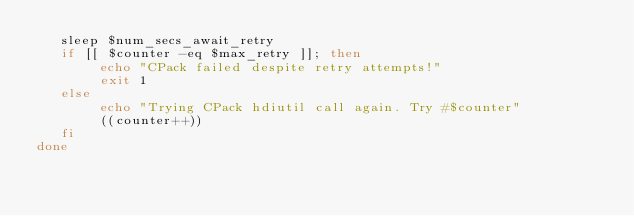<code> <loc_0><loc_0><loc_500><loc_500><_Bash_>   sleep $num_secs_await_retry
   if [[ $counter -eq $max_retry ]]; then
        echo "CPack failed despite retry attempts!"
        exit 1
   else
        echo "Trying CPack hdiutil call again. Try #$counter"
        ((counter++))
   fi
done
</code> 